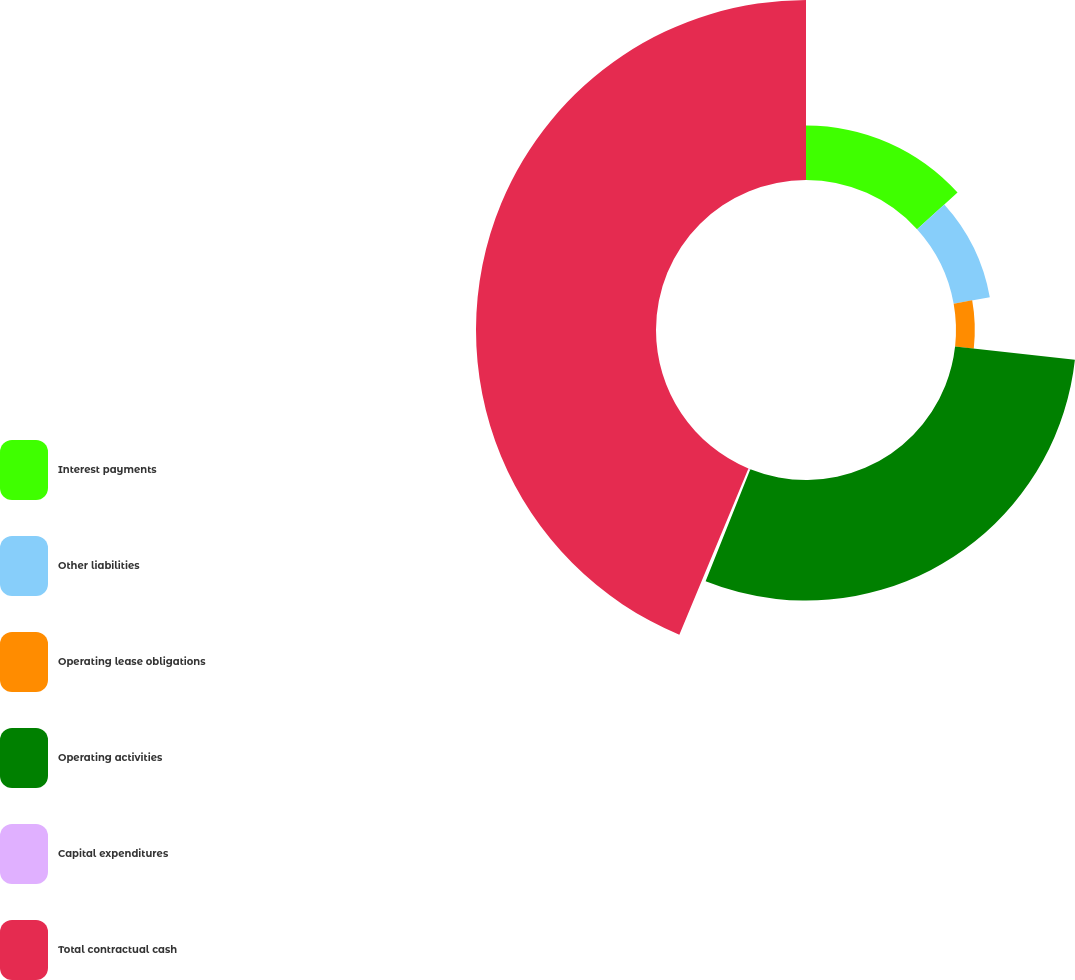Convert chart. <chart><loc_0><loc_0><loc_500><loc_500><pie_chart><fcel>Interest payments<fcel>Other liabilities<fcel>Operating lease obligations<fcel>Operating activities<fcel>Capital expenditures<fcel>Total contractual cash<nl><fcel>13.27%<fcel>8.92%<fcel>4.57%<fcel>29.29%<fcel>0.22%<fcel>43.73%<nl></chart> 